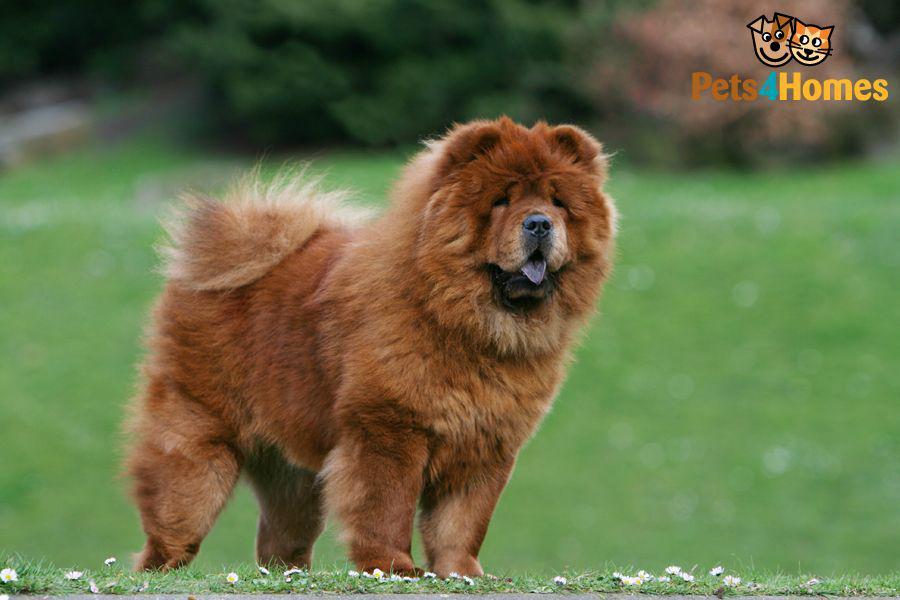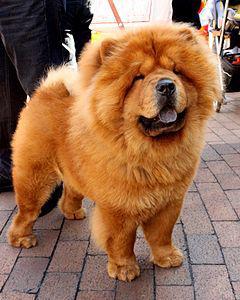The first image is the image on the left, the second image is the image on the right. Considering the images on both sides, is "Right image shows a chow dog standing with its body turned leftward." valid? Answer yes or no. No. The first image is the image on the left, the second image is the image on the right. Analyze the images presented: Is the assertion "At least one of the furry dogs is standing in the grass." valid? Answer yes or no. Yes. 